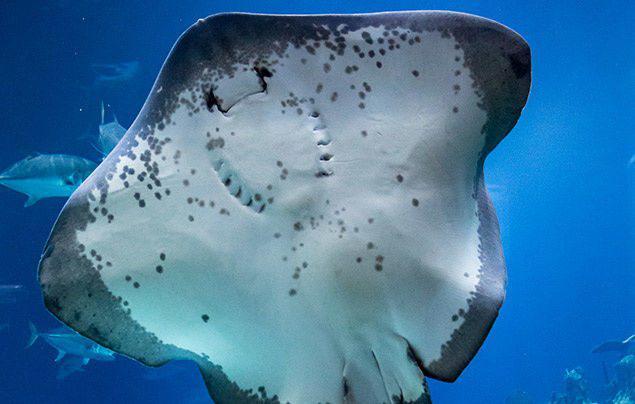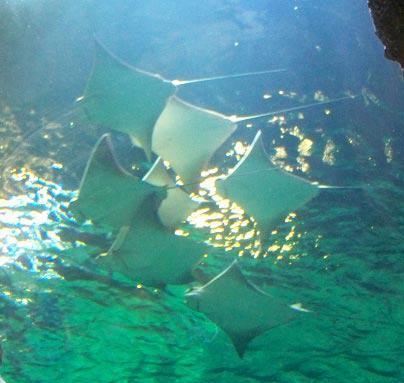The first image is the image on the left, the second image is the image on the right. Examine the images to the left and right. Is the description "There are sting rays in both images." accurate? Answer yes or no. Yes. The first image is the image on the left, the second image is the image on the right. Examine the images to the left and right. Is the description "There is a human visible in one of the images." accurate? Answer yes or no. No. 